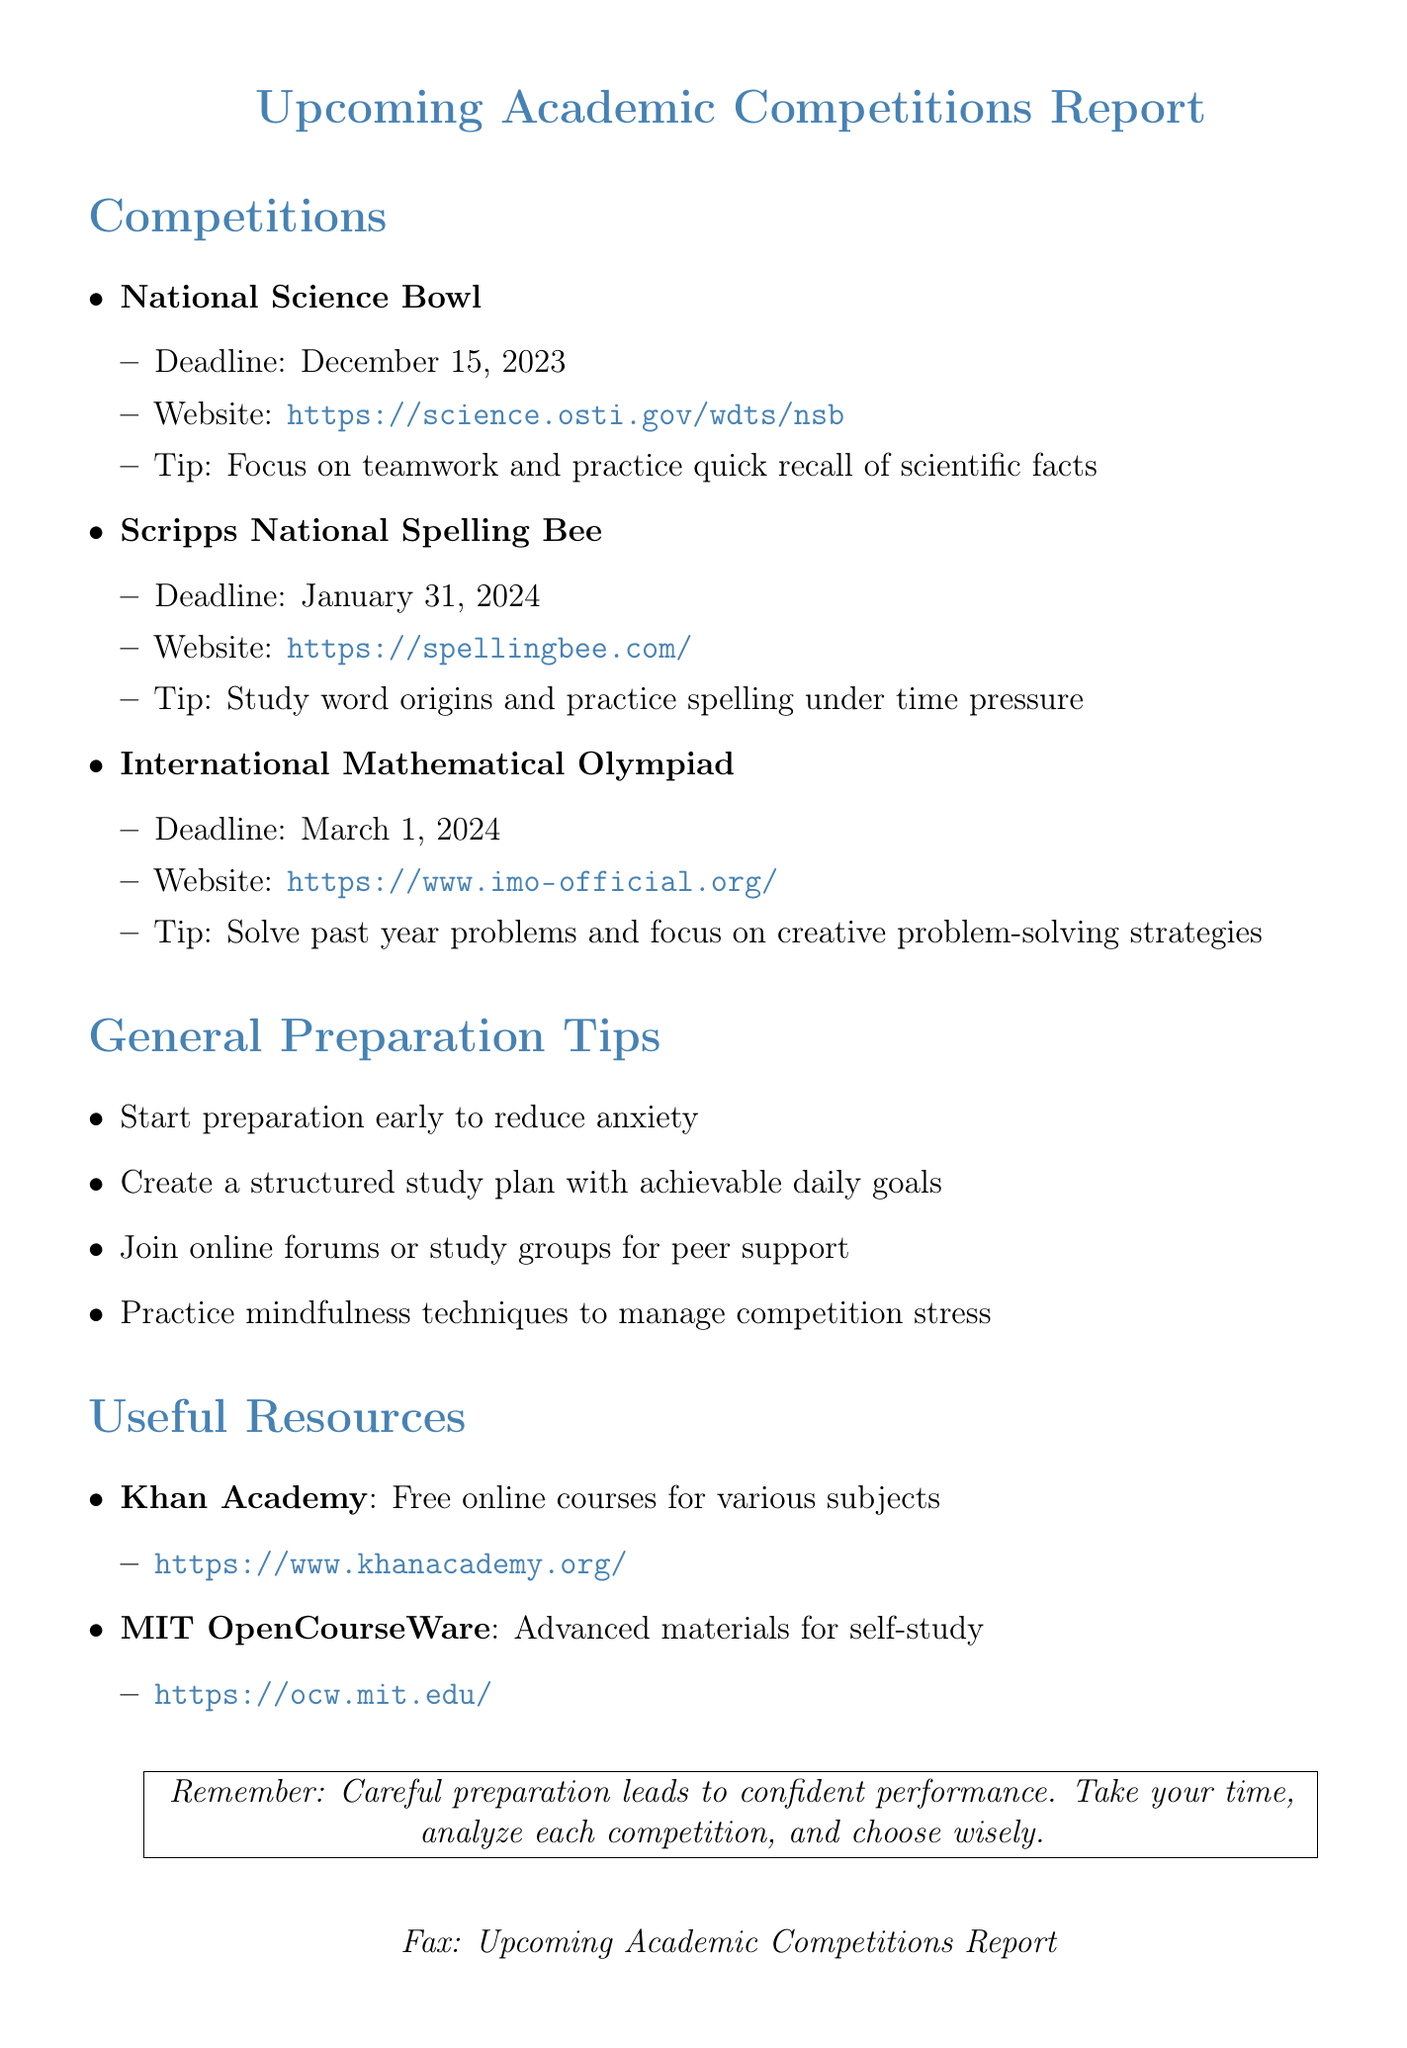What is the deadline for the National Science Bowl? The deadline for the National Science Bowl is explicitly mentioned in the document as December 15, 2023.
Answer: December 15, 2023 What is the main tip for preparing for the Scripps National Spelling Bee? The document provides a tip specifically for the Scripps National Spelling Bee, which is to study word origins and practice spelling under time pressure.
Answer: Study word origins and practice spelling under time pressure How many competitions are listed in the document? The document lists the National Science Bowl, Scripps National Spelling Bee, and International Mathematical Olympiad, totaling three competitions.
Answer: Three What is one way to reduce anxiety during preparation? The document states that starting preparation early can help in reducing anxiety.
Answer: Start preparation early Which website is associated with the International Mathematical Olympiad? The document includes the specific website to refer to for the International Mathematical Olympiad, which is https://www.imo-official.org/.
Answer: https://www.imo-official.org/ What type of resources does Khan Academy offer? The document mentions that Khan Academy provides free online courses for various subjects.
Answer: Free online courses for various subjects What should you create to organize your study preparation? The document suggests creating a structured study plan with achievable daily goals to organize study preparation.
Answer: Structured study plan What is a key reminder at the end of the document? At the end of the document, it highlights that careful preparation leads to confident performance.
Answer: Careful preparation leads to confident performance 